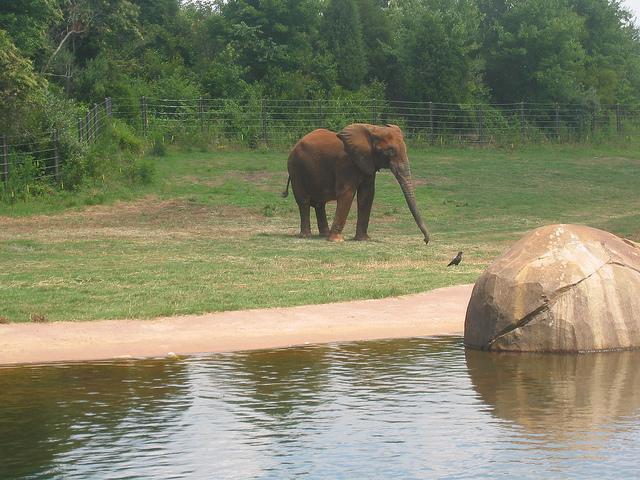How many people do you see?
Give a very brief answer. 0. 